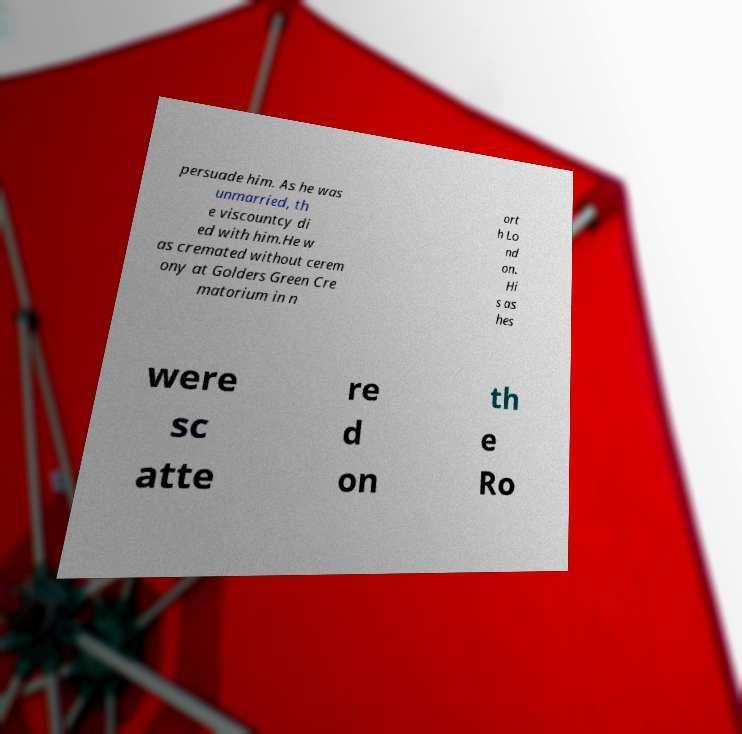For documentation purposes, I need the text within this image transcribed. Could you provide that? persuade him. As he was unmarried, th e viscountcy di ed with him.He w as cremated without cerem ony at Golders Green Cre matorium in n ort h Lo nd on. Hi s as hes were sc atte re d on th e Ro 